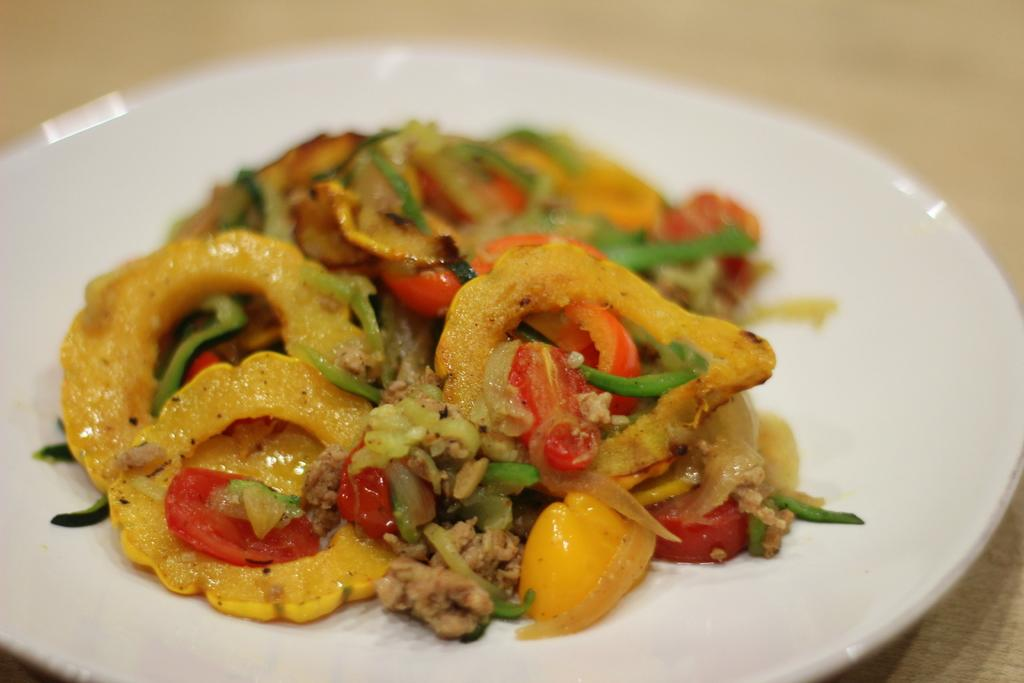What is located in the center of the image? There is a plate in the center of the image. What is on the plate? There is food on the plate. What piece of furniture is at the bottom of the image? There is a table at the bottom of the image. How much does the cave cost in the image? There is no cave present in the image, so it is not possible to determine its cost. 